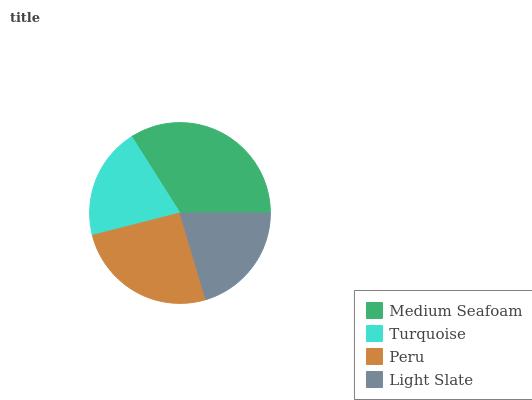Is Turquoise the minimum?
Answer yes or no. Yes. Is Medium Seafoam the maximum?
Answer yes or no. Yes. Is Peru the minimum?
Answer yes or no. No. Is Peru the maximum?
Answer yes or no. No. Is Peru greater than Turquoise?
Answer yes or no. Yes. Is Turquoise less than Peru?
Answer yes or no. Yes. Is Turquoise greater than Peru?
Answer yes or no. No. Is Peru less than Turquoise?
Answer yes or no. No. Is Peru the high median?
Answer yes or no. Yes. Is Light Slate the low median?
Answer yes or no. Yes. Is Light Slate the high median?
Answer yes or no. No. Is Turquoise the low median?
Answer yes or no. No. 